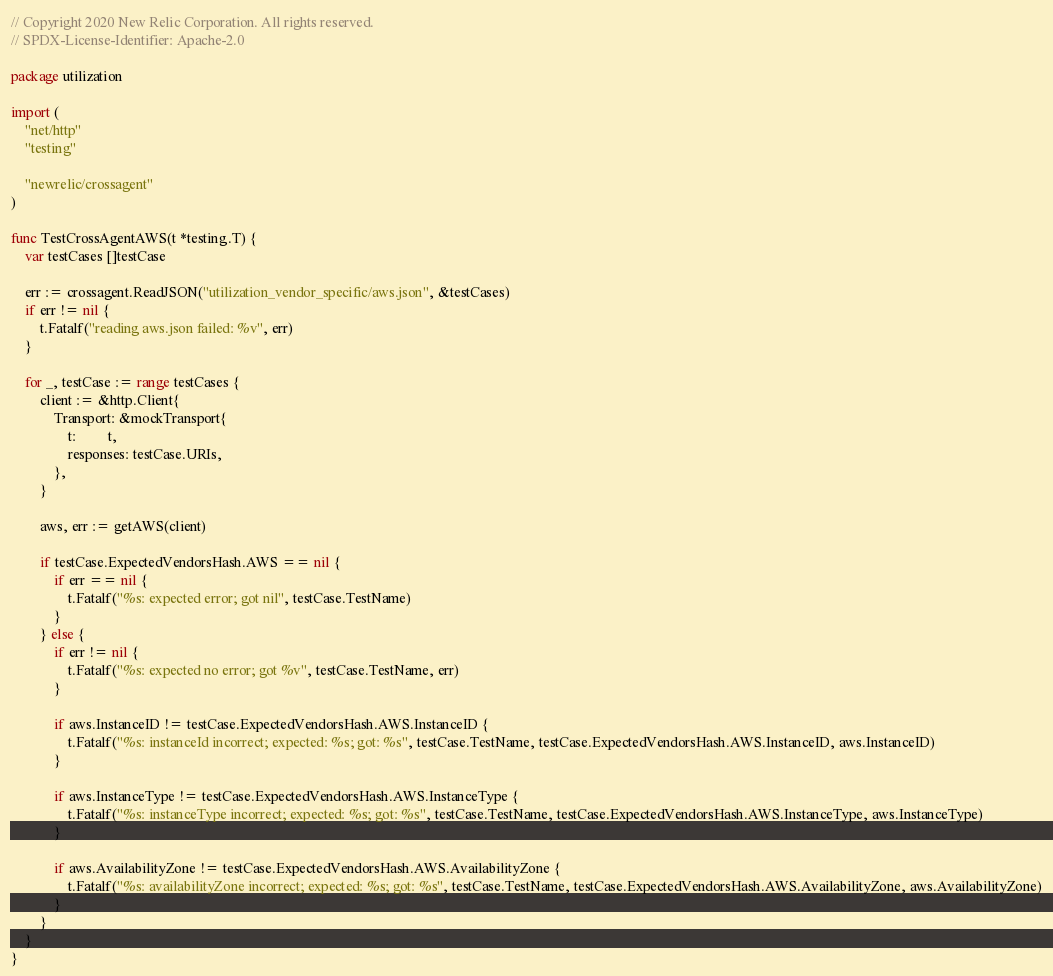<code> <loc_0><loc_0><loc_500><loc_500><_Go_>// Copyright 2020 New Relic Corporation. All rights reserved.
// SPDX-License-Identifier: Apache-2.0

package utilization

import (
	"net/http"
	"testing"

	"newrelic/crossagent"
)

func TestCrossAgentAWS(t *testing.T) {
	var testCases []testCase

	err := crossagent.ReadJSON("utilization_vendor_specific/aws.json", &testCases)
	if err != nil {
		t.Fatalf("reading aws.json failed: %v", err)
	}

	for _, testCase := range testCases {
		client := &http.Client{
			Transport: &mockTransport{
				t:         t,
				responses: testCase.URIs,
			},
		}

		aws, err := getAWS(client)

		if testCase.ExpectedVendorsHash.AWS == nil {
			if err == nil {
				t.Fatalf("%s: expected error; got nil", testCase.TestName)
			}
		} else {
			if err != nil {
				t.Fatalf("%s: expected no error; got %v", testCase.TestName, err)
			}

			if aws.InstanceID != testCase.ExpectedVendorsHash.AWS.InstanceID {
				t.Fatalf("%s: instanceId incorrect; expected: %s; got: %s", testCase.TestName, testCase.ExpectedVendorsHash.AWS.InstanceID, aws.InstanceID)
			}

			if aws.InstanceType != testCase.ExpectedVendorsHash.AWS.InstanceType {
				t.Fatalf("%s: instanceType incorrect; expected: %s; got: %s", testCase.TestName, testCase.ExpectedVendorsHash.AWS.InstanceType, aws.InstanceType)
			}

			if aws.AvailabilityZone != testCase.ExpectedVendorsHash.AWS.AvailabilityZone {
				t.Fatalf("%s: availabilityZone incorrect; expected: %s; got: %s", testCase.TestName, testCase.ExpectedVendorsHash.AWS.AvailabilityZone, aws.AvailabilityZone)
			}
		}
	}
}
</code> 